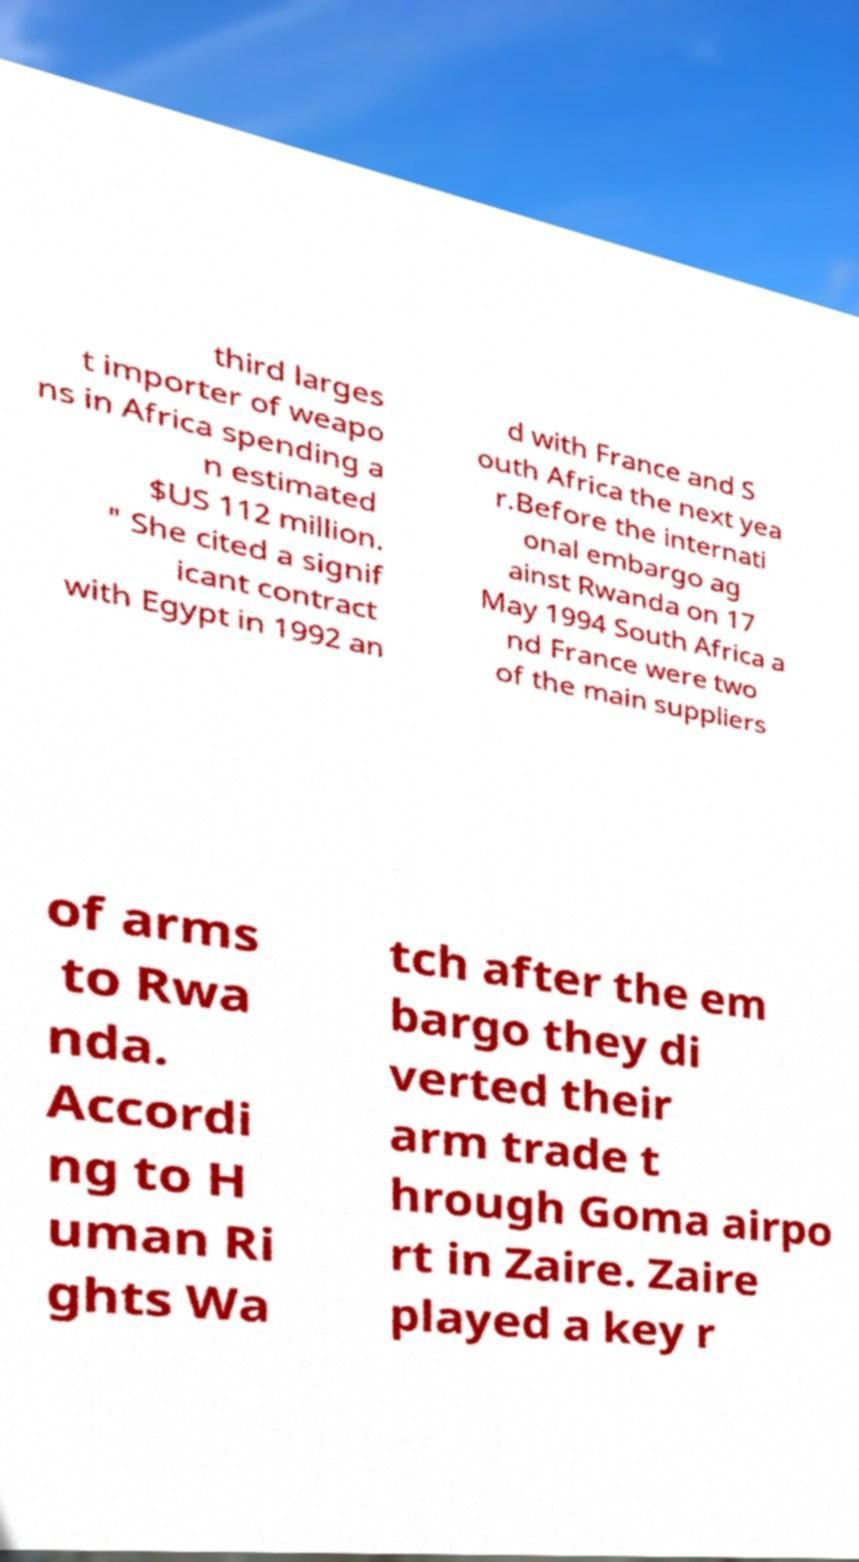Can you accurately transcribe the text from the provided image for me? third larges t importer of weapo ns in Africa spending a n estimated $US 112 million. " She cited a signif icant contract with Egypt in 1992 an d with France and S outh Africa the next yea r.Before the internati onal embargo ag ainst Rwanda on 17 May 1994 South Africa a nd France were two of the main suppliers of arms to Rwa nda. Accordi ng to H uman Ri ghts Wa tch after the em bargo they di verted their arm trade t hrough Goma airpo rt in Zaire. Zaire played a key r 